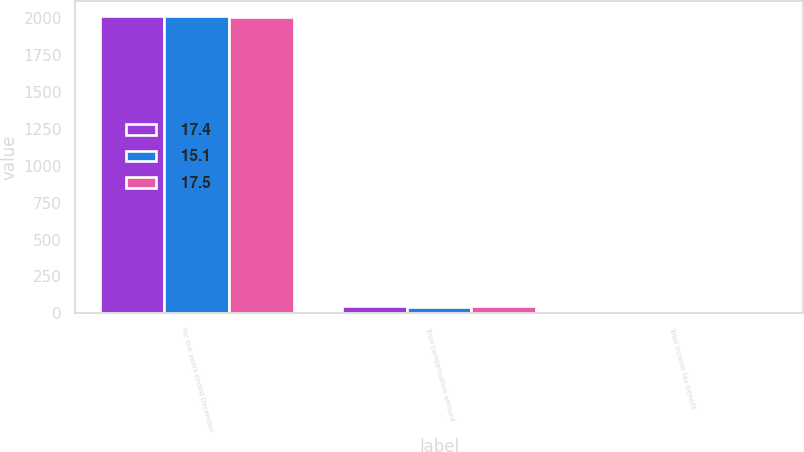Convert chart. <chart><loc_0><loc_0><loc_500><loc_500><stacked_bar_chart><ecel><fcel>For the years ended December<fcel>Total compensation amount<fcel>Total income tax benefit<nl><fcel>17.4<fcel>2012<fcel>50.5<fcel>17.5<nl><fcel>15.1<fcel>2011<fcel>43.5<fcel>15.1<nl><fcel>17.5<fcel>2010<fcel>49.5<fcel>17.4<nl></chart> 